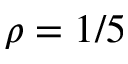Convert formula to latex. <formula><loc_0><loc_0><loc_500><loc_500>\rho = 1 / 5</formula> 